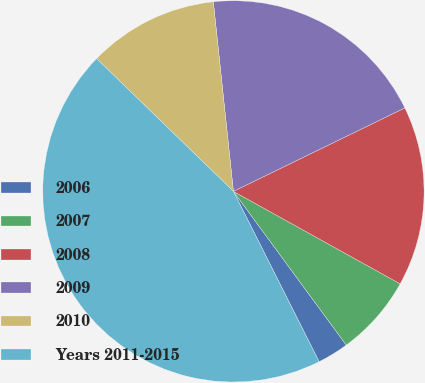<chart> <loc_0><loc_0><loc_500><loc_500><pie_chart><fcel>2006<fcel>2007<fcel>2008<fcel>2009<fcel>2010<fcel>Years 2011-2015<nl><fcel>2.66%<fcel>6.86%<fcel>15.27%<fcel>19.47%<fcel>11.06%<fcel>44.68%<nl></chart> 